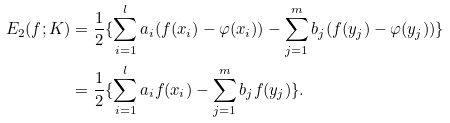Convert formula to latex. <formula><loc_0><loc_0><loc_500><loc_500>E _ { 2 } ( f ; K ) & = \frac { 1 } { 2 } \{ \sum _ { i = 1 } ^ { l } a _ { i } ( f ( x _ { i } ) - \varphi ( x _ { i } ) ) - \sum _ { j = 1 } ^ { m } b _ { j } ( f ( y _ { j } ) - \varphi ( y _ { j } ) ) \} \\ & = \frac { 1 } { 2 } \{ \sum _ { i = 1 } ^ { l } a _ { i } f ( x _ { i } ) - \sum _ { j = 1 } ^ { m } b _ { j } f ( y _ { j } ) \} .</formula> 